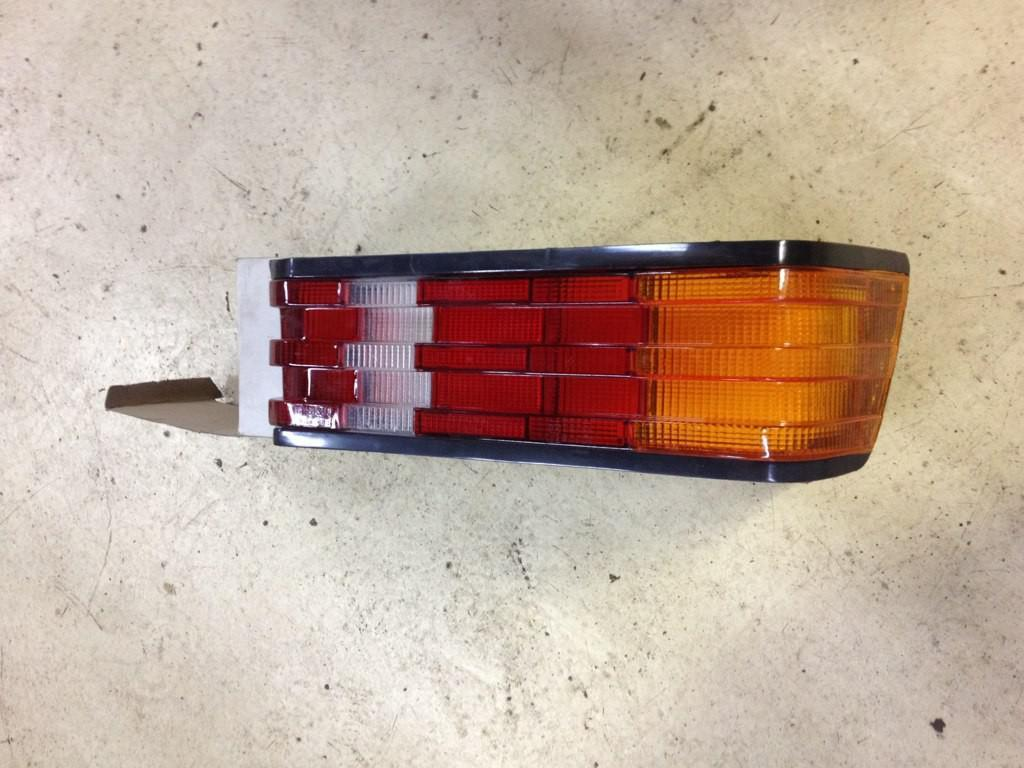What is the main object in the image? There is a car rear light part in the image. How is the car rear light part positioned? The car rear light part is placed on a cardboard box. What is the cardboard box resting on? The cardboard box is on a surface. What type of wound can be seen on the car rear light part in the image? There is no wound present on the car rear light part in the image. What ingredients are used to make the stew in the image? There is no stew present in the image; it features a car rear light part placed on a cardboard box. 